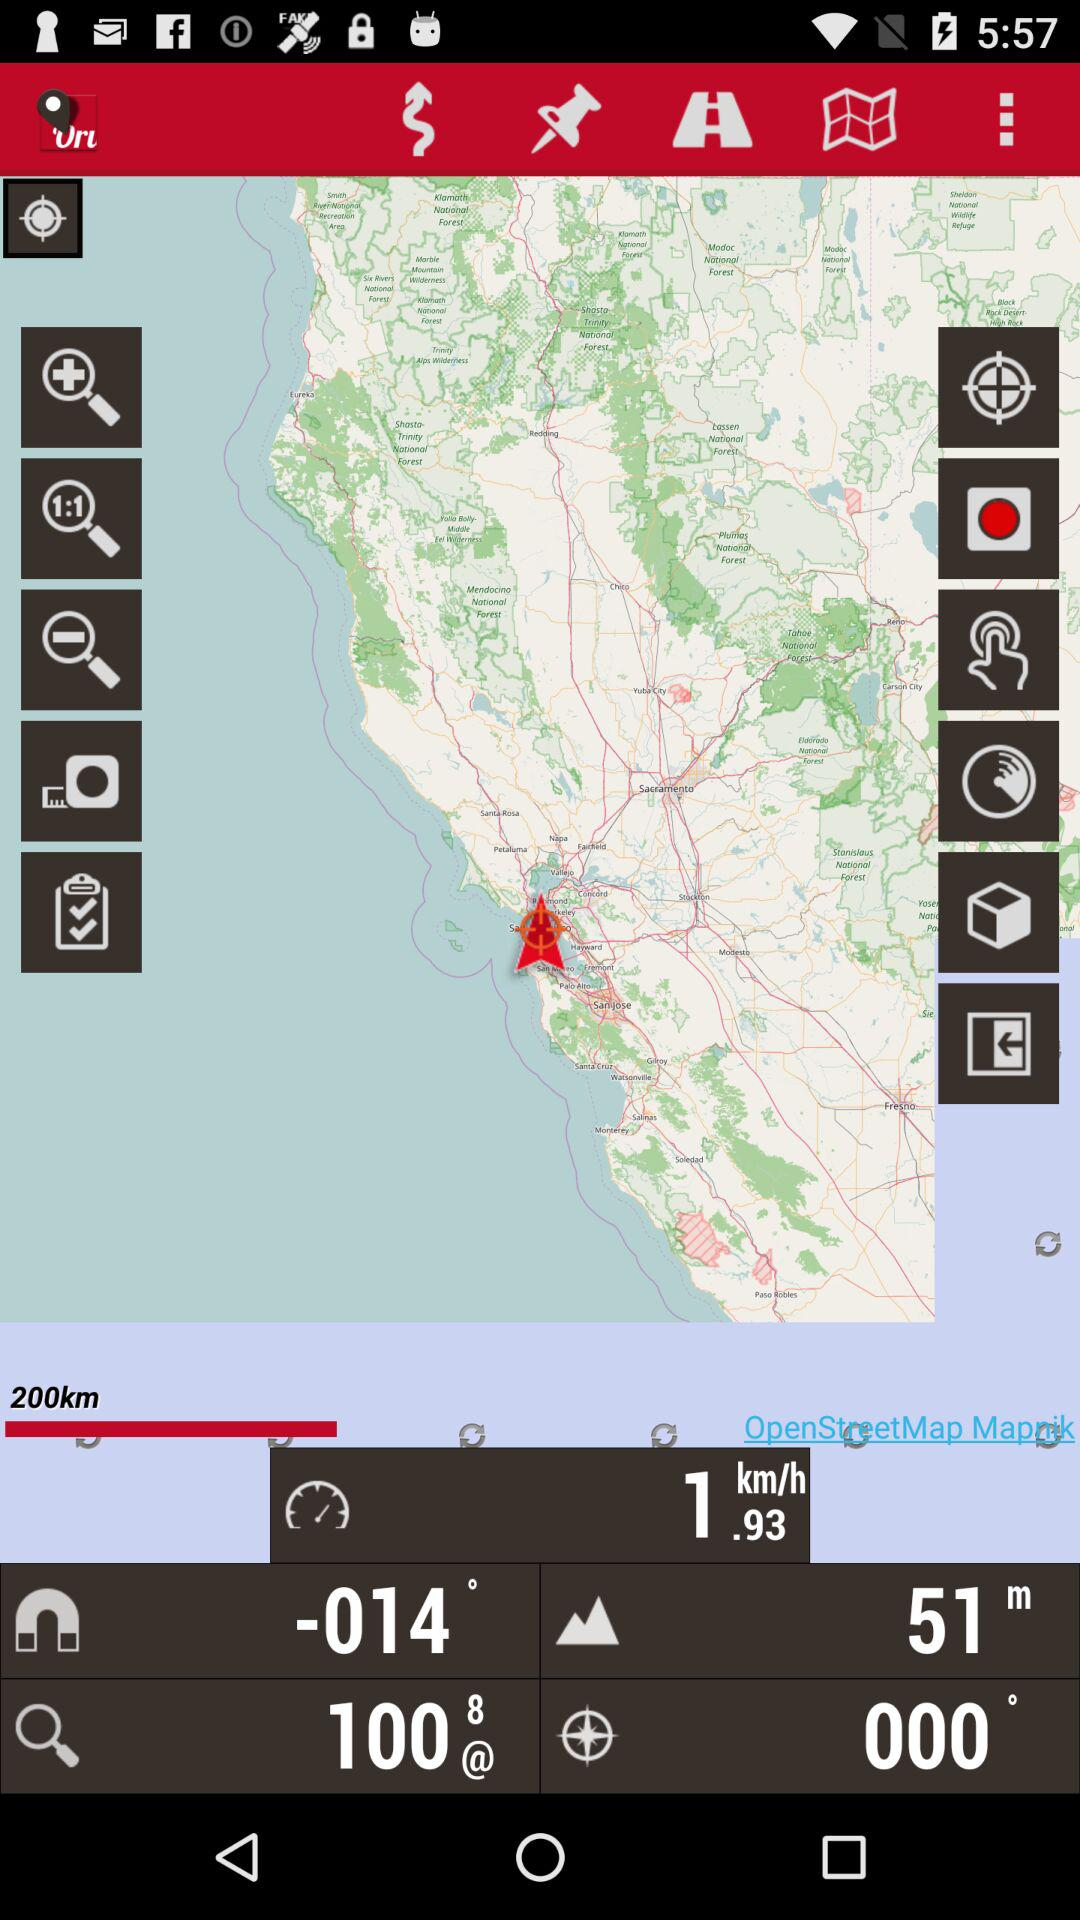What is the elevation? The elevation is 51 m. 